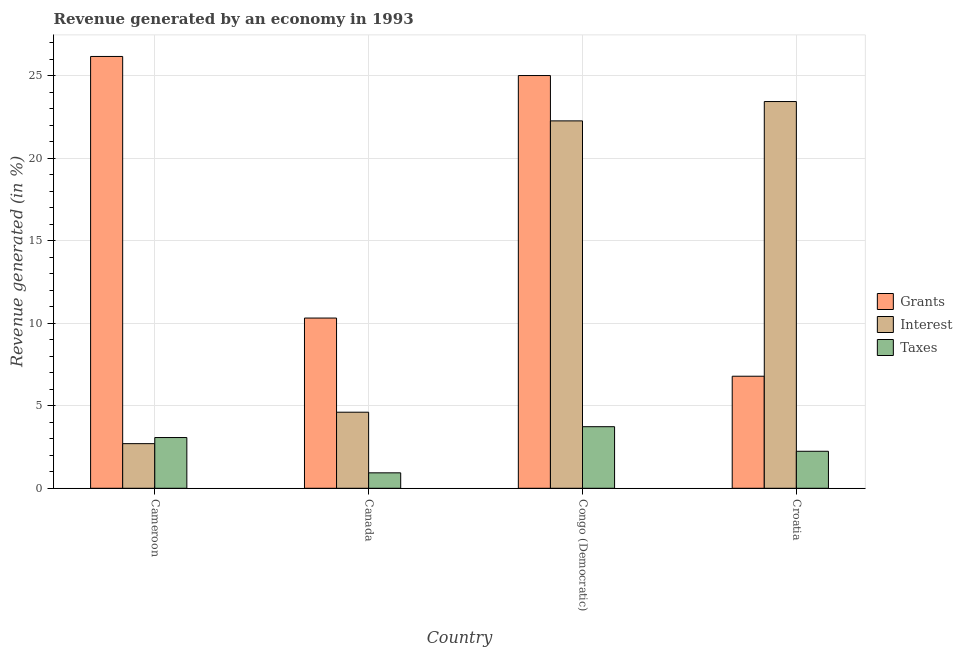How many groups of bars are there?
Give a very brief answer. 4. Are the number of bars on each tick of the X-axis equal?
Your answer should be very brief. Yes. How many bars are there on the 4th tick from the left?
Provide a short and direct response. 3. What is the label of the 3rd group of bars from the left?
Give a very brief answer. Congo (Democratic). In how many cases, is the number of bars for a given country not equal to the number of legend labels?
Provide a short and direct response. 0. What is the percentage of revenue generated by taxes in Canada?
Provide a succinct answer. 0.94. Across all countries, what is the maximum percentage of revenue generated by taxes?
Your answer should be very brief. 3.73. Across all countries, what is the minimum percentage of revenue generated by taxes?
Provide a short and direct response. 0.94. In which country was the percentage of revenue generated by taxes maximum?
Your answer should be compact. Congo (Democratic). In which country was the percentage of revenue generated by taxes minimum?
Offer a terse response. Canada. What is the total percentage of revenue generated by taxes in the graph?
Keep it short and to the point. 9.98. What is the difference between the percentage of revenue generated by interest in Canada and that in Congo (Democratic)?
Your answer should be compact. -17.65. What is the difference between the percentage of revenue generated by interest in Croatia and the percentage of revenue generated by grants in Congo (Democratic)?
Your answer should be compact. -1.58. What is the average percentage of revenue generated by interest per country?
Keep it short and to the point. 13.25. What is the difference between the percentage of revenue generated by interest and percentage of revenue generated by grants in Cameroon?
Provide a short and direct response. -23.46. What is the ratio of the percentage of revenue generated by taxes in Congo (Democratic) to that in Croatia?
Provide a short and direct response. 1.66. Is the percentage of revenue generated by taxes in Cameroon less than that in Croatia?
Keep it short and to the point. No. Is the difference between the percentage of revenue generated by interest in Canada and Congo (Democratic) greater than the difference between the percentage of revenue generated by taxes in Canada and Congo (Democratic)?
Ensure brevity in your answer.  No. What is the difference between the highest and the second highest percentage of revenue generated by interest?
Provide a succinct answer. 1.17. What is the difference between the highest and the lowest percentage of revenue generated by taxes?
Your answer should be very brief. 2.8. In how many countries, is the percentage of revenue generated by taxes greater than the average percentage of revenue generated by taxes taken over all countries?
Provide a short and direct response. 2. Is the sum of the percentage of revenue generated by grants in Cameroon and Canada greater than the maximum percentage of revenue generated by interest across all countries?
Provide a succinct answer. Yes. What does the 3rd bar from the left in Croatia represents?
Offer a terse response. Taxes. What does the 1st bar from the right in Congo (Democratic) represents?
Ensure brevity in your answer.  Taxes. Is it the case that in every country, the sum of the percentage of revenue generated by grants and percentage of revenue generated by interest is greater than the percentage of revenue generated by taxes?
Give a very brief answer. Yes. How many countries are there in the graph?
Give a very brief answer. 4. What is the difference between two consecutive major ticks on the Y-axis?
Offer a terse response. 5. Are the values on the major ticks of Y-axis written in scientific E-notation?
Offer a very short reply. No. Does the graph contain grids?
Make the answer very short. Yes. How many legend labels are there?
Keep it short and to the point. 3. How are the legend labels stacked?
Offer a very short reply. Vertical. What is the title of the graph?
Ensure brevity in your answer.  Revenue generated by an economy in 1993. What is the label or title of the X-axis?
Your response must be concise. Country. What is the label or title of the Y-axis?
Offer a terse response. Revenue generated (in %). What is the Revenue generated (in %) of Grants in Cameroon?
Your answer should be very brief. 26.16. What is the Revenue generated (in %) in Interest in Cameroon?
Make the answer very short. 2.7. What is the Revenue generated (in %) of Taxes in Cameroon?
Give a very brief answer. 3.07. What is the Revenue generated (in %) of Grants in Canada?
Give a very brief answer. 10.31. What is the Revenue generated (in %) of Interest in Canada?
Your answer should be very brief. 4.61. What is the Revenue generated (in %) of Taxes in Canada?
Your answer should be compact. 0.94. What is the Revenue generated (in %) of Grants in Congo (Democratic)?
Your answer should be compact. 25.01. What is the Revenue generated (in %) in Interest in Congo (Democratic)?
Your answer should be compact. 22.26. What is the Revenue generated (in %) in Taxes in Congo (Democratic)?
Provide a succinct answer. 3.73. What is the Revenue generated (in %) in Grants in Croatia?
Offer a very short reply. 6.79. What is the Revenue generated (in %) in Interest in Croatia?
Provide a succinct answer. 23.43. What is the Revenue generated (in %) in Taxes in Croatia?
Provide a short and direct response. 2.24. Across all countries, what is the maximum Revenue generated (in %) of Grants?
Make the answer very short. 26.16. Across all countries, what is the maximum Revenue generated (in %) of Interest?
Ensure brevity in your answer.  23.43. Across all countries, what is the maximum Revenue generated (in %) in Taxes?
Provide a short and direct response. 3.73. Across all countries, what is the minimum Revenue generated (in %) in Grants?
Make the answer very short. 6.79. Across all countries, what is the minimum Revenue generated (in %) in Interest?
Keep it short and to the point. 2.7. Across all countries, what is the minimum Revenue generated (in %) of Taxes?
Make the answer very short. 0.94. What is the total Revenue generated (in %) of Grants in the graph?
Ensure brevity in your answer.  68.28. What is the total Revenue generated (in %) in Interest in the graph?
Provide a succinct answer. 53.01. What is the total Revenue generated (in %) in Taxes in the graph?
Keep it short and to the point. 9.98. What is the difference between the Revenue generated (in %) of Grants in Cameroon and that in Canada?
Offer a very short reply. 15.85. What is the difference between the Revenue generated (in %) of Interest in Cameroon and that in Canada?
Give a very brief answer. -1.9. What is the difference between the Revenue generated (in %) of Taxes in Cameroon and that in Canada?
Your answer should be compact. 2.14. What is the difference between the Revenue generated (in %) of Grants in Cameroon and that in Congo (Democratic)?
Your answer should be very brief. 1.16. What is the difference between the Revenue generated (in %) in Interest in Cameroon and that in Congo (Democratic)?
Provide a short and direct response. -19.56. What is the difference between the Revenue generated (in %) in Taxes in Cameroon and that in Congo (Democratic)?
Offer a terse response. -0.66. What is the difference between the Revenue generated (in %) in Grants in Cameroon and that in Croatia?
Provide a succinct answer. 19.37. What is the difference between the Revenue generated (in %) of Interest in Cameroon and that in Croatia?
Your response must be concise. -20.73. What is the difference between the Revenue generated (in %) of Taxes in Cameroon and that in Croatia?
Provide a succinct answer. 0.83. What is the difference between the Revenue generated (in %) of Grants in Canada and that in Congo (Democratic)?
Your response must be concise. -14.69. What is the difference between the Revenue generated (in %) in Interest in Canada and that in Congo (Democratic)?
Give a very brief answer. -17.65. What is the difference between the Revenue generated (in %) of Taxes in Canada and that in Congo (Democratic)?
Ensure brevity in your answer.  -2.8. What is the difference between the Revenue generated (in %) of Grants in Canada and that in Croatia?
Offer a terse response. 3.53. What is the difference between the Revenue generated (in %) of Interest in Canada and that in Croatia?
Provide a succinct answer. -18.82. What is the difference between the Revenue generated (in %) in Taxes in Canada and that in Croatia?
Offer a very short reply. -1.31. What is the difference between the Revenue generated (in %) in Grants in Congo (Democratic) and that in Croatia?
Provide a short and direct response. 18.22. What is the difference between the Revenue generated (in %) of Interest in Congo (Democratic) and that in Croatia?
Ensure brevity in your answer.  -1.17. What is the difference between the Revenue generated (in %) of Taxes in Congo (Democratic) and that in Croatia?
Your response must be concise. 1.49. What is the difference between the Revenue generated (in %) in Grants in Cameroon and the Revenue generated (in %) in Interest in Canada?
Offer a very short reply. 21.55. What is the difference between the Revenue generated (in %) in Grants in Cameroon and the Revenue generated (in %) in Taxes in Canada?
Your response must be concise. 25.23. What is the difference between the Revenue generated (in %) of Interest in Cameroon and the Revenue generated (in %) of Taxes in Canada?
Ensure brevity in your answer.  1.77. What is the difference between the Revenue generated (in %) of Grants in Cameroon and the Revenue generated (in %) of Interest in Congo (Democratic)?
Provide a succinct answer. 3.9. What is the difference between the Revenue generated (in %) of Grants in Cameroon and the Revenue generated (in %) of Taxes in Congo (Democratic)?
Ensure brevity in your answer.  22.43. What is the difference between the Revenue generated (in %) of Interest in Cameroon and the Revenue generated (in %) of Taxes in Congo (Democratic)?
Give a very brief answer. -1.03. What is the difference between the Revenue generated (in %) of Grants in Cameroon and the Revenue generated (in %) of Interest in Croatia?
Your response must be concise. 2.73. What is the difference between the Revenue generated (in %) in Grants in Cameroon and the Revenue generated (in %) in Taxes in Croatia?
Your response must be concise. 23.92. What is the difference between the Revenue generated (in %) of Interest in Cameroon and the Revenue generated (in %) of Taxes in Croatia?
Provide a short and direct response. 0.46. What is the difference between the Revenue generated (in %) of Grants in Canada and the Revenue generated (in %) of Interest in Congo (Democratic)?
Your answer should be very brief. -11.95. What is the difference between the Revenue generated (in %) in Grants in Canada and the Revenue generated (in %) in Taxes in Congo (Democratic)?
Ensure brevity in your answer.  6.58. What is the difference between the Revenue generated (in %) of Interest in Canada and the Revenue generated (in %) of Taxes in Congo (Democratic)?
Offer a very short reply. 0.88. What is the difference between the Revenue generated (in %) of Grants in Canada and the Revenue generated (in %) of Interest in Croatia?
Offer a terse response. -13.12. What is the difference between the Revenue generated (in %) in Grants in Canada and the Revenue generated (in %) in Taxes in Croatia?
Your answer should be compact. 8.07. What is the difference between the Revenue generated (in %) of Interest in Canada and the Revenue generated (in %) of Taxes in Croatia?
Offer a very short reply. 2.37. What is the difference between the Revenue generated (in %) in Grants in Congo (Democratic) and the Revenue generated (in %) in Interest in Croatia?
Make the answer very short. 1.58. What is the difference between the Revenue generated (in %) in Grants in Congo (Democratic) and the Revenue generated (in %) in Taxes in Croatia?
Offer a terse response. 22.77. What is the difference between the Revenue generated (in %) in Interest in Congo (Democratic) and the Revenue generated (in %) in Taxes in Croatia?
Offer a terse response. 20.02. What is the average Revenue generated (in %) in Grants per country?
Make the answer very short. 17.07. What is the average Revenue generated (in %) in Interest per country?
Provide a short and direct response. 13.25. What is the average Revenue generated (in %) in Taxes per country?
Your response must be concise. 2.5. What is the difference between the Revenue generated (in %) in Grants and Revenue generated (in %) in Interest in Cameroon?
Ensure brevity in your answer.  23.46. What is the difference between the Revenue generated (in %) in Grants and Revenue generated (in %) in Taxes in Cameroon?
Offer a very short reply. 23.09. What is the difference between the Revenue generated (in %) in Interest and Revenue generated (in %) in Taxes in Cameroon?
Provide a succinct answer. -0.37. What is the difference between the Revenue generated (in %) in Grants and Revenue generated (in %) in Interest in Canada?
Your response must be concise. 5.71. What is the difference between the Revenue generated (in %) in Grants and Revenue generated (in %) in Taxes in Canada?
Ensure brevity in your answer.  9.38. What is the difference between the Revenue generated (in %) in Interest and Revenue generated (in %) in Taxes in Canada?
Ensure brevity in your answer.  3.67. What is the difference between the Revenue generated (in %) of Grants and Revenue generated (in %) of Interest in Congo (Democratic)?
Give a very brief answer. 2.75. What is the difference between the Revenue generated (in %) of Grants and Revenue generated (in %) of Taxes in Congo (Democratic)?
Provide a short and direct response. 21.28. What is the difference between the Revenue generated (in %) in Interest and Revenue generated (in %) in Taxes in Congo (Democratic)?
Provide a succinct answer. 18.53. What is the difference between the Revenue generated (in %) in Grants and Revenue generated (in %) in Interest in Croatia?
Your response must be concise. -16.64. What is the difference between the Revenue generated (in %) of Grants and Revenue generated (in %) of Taxes in Croatia?
Your response must be concise. 4.55. What is the difference between the Revenue generated (in %) in Interest and Revenue generated (in %) in Taxes in Croatia?
Provide a short and direct response. 21.19. What is the ratio of the Revenue generated (in %) in Grants in Cameroon to that in Canada?
Make the answer very short. 2.54. What is the ratio of the Revenue generated (in %) in Interest in Cameroon to that in Canada?
Your answer should be compact. 0.59. What is the ratio of the Revenue generated (in %) in Taxes in Cameroon to that in Canada?
Provide a succinct answer. 3.29. What is the ratio of the Revenue generated (in %) in Grants in Cameroon to that in Congo (Democratic)?
Provide a short and direct response. 1.05. What is the ratio of the Revenue generated (in %) in Interest in Cameroon to that in Congo (Democratic)?
Your answer should be compact. 0.12. What is the ratio of the Revenue generated (in %) of Taxes in Cameroon to that in Congo (Democratic)?
Your response must be concise. 0.82. What is the ratio of the Revenue generated (in %) in Grants in Cameroon to that in Croatia?
Give a very brief answer. 3.85. What is the ratio of the Revenue generated (in %) of Interest in Cameroon to that in Croatia?
Your answer should be compact. 0.12. What is the ratio of the Revenue generated (in %) in Taxes in Cameroon to that in Croatia?
Give a very brief answer. 1.37. What is the ratio of the Revenue generated (in %) in Grants in Canada to that in Congo (Democratic)?
Your answer should be compact. 0.41. What is the ratio of the Revenue generated (in %) of Interest in Canada to that in Congo (Democratic)?
Provide a short and direct response. 0.21. What is the ratio of the Revenue generated (in %) in Taxes in Canada to that in Congo (Democratic)?
Your answer should be very brief. 0.25. What is the ratio of the Revenue generated (in %) in Grants in Canada to that in Croatia?
Provide a succinct answer. 1.52. What is the ratio of the Revenue generated (in %) of Interest in Canada to that in Croatia?
Your answer should be compact. 0.2. What is the ratio of the Revenue generated (in %) in Taxes in Canada to that in Croatia?
Offer a very short reply. 0.42. What is the ratio of the Revenue generated (in %) in Grants in Congo (Democratic) to that in Croatia?
Provide a succinct answer. 3.68. What is the ratio of the Revenue generated (in %) in Interest in Congo (Democratic) to that in Croatia?
Provide a short and direct response. 0.95. What is the ratio of the Revenue generated (in %) of Taxes in Congo (Democratic) to that in Croatia?
Offer a very short reply. 1.66. What is the difference between the highest and the second highest Revenue generated (in %) in Grants?
Ensure brevity in your answer.  1.16. What is the difference between the highest and the second highest Revenue generated (in %) of Interest?
Keep it short and to the point. 1.17. What is the difference between the highest and the second highest Revenue generated (in %) in Taxes?
Make the answer very short. 0.66. What is the difference between the highest and the lowest Revenue generated (in %) of Grants?
Ensure brevity in your answer.  19.37. What is the difference between the highest and the lowest Revenue generated (in %) in Interest?
Your response must be concise. 20.73. What is the difference between the highest and the lowest Revenue generated (in %) of Taxes?
Provide a short and direct response. 2.8. 